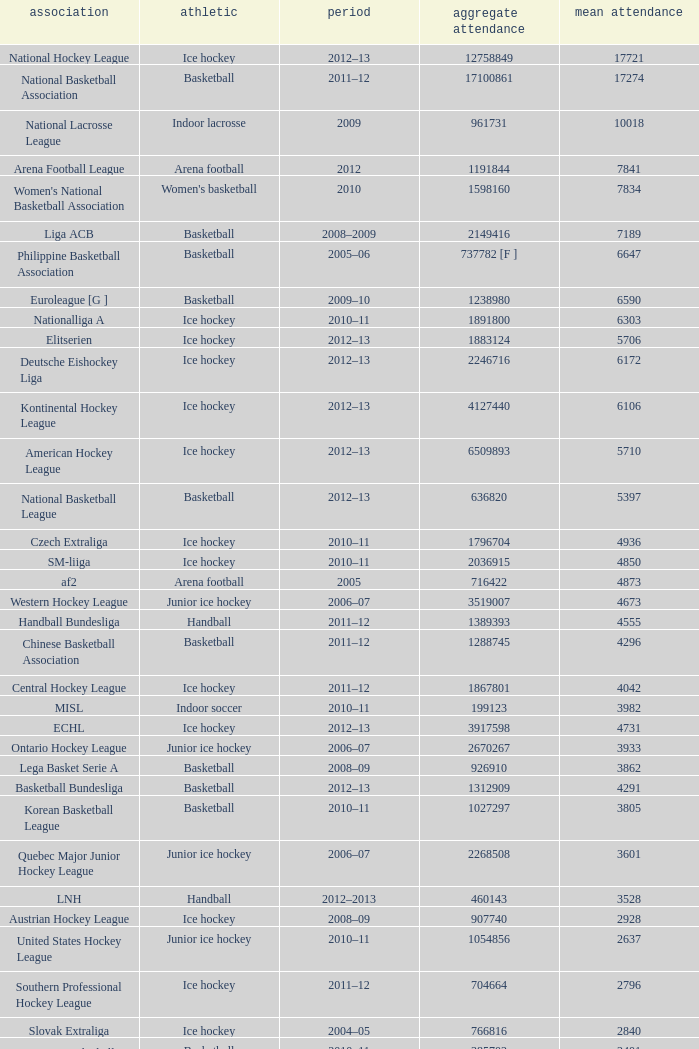What's the total attendance in rink hockey when the average attendance was smaller than 4850? 115000.0. 